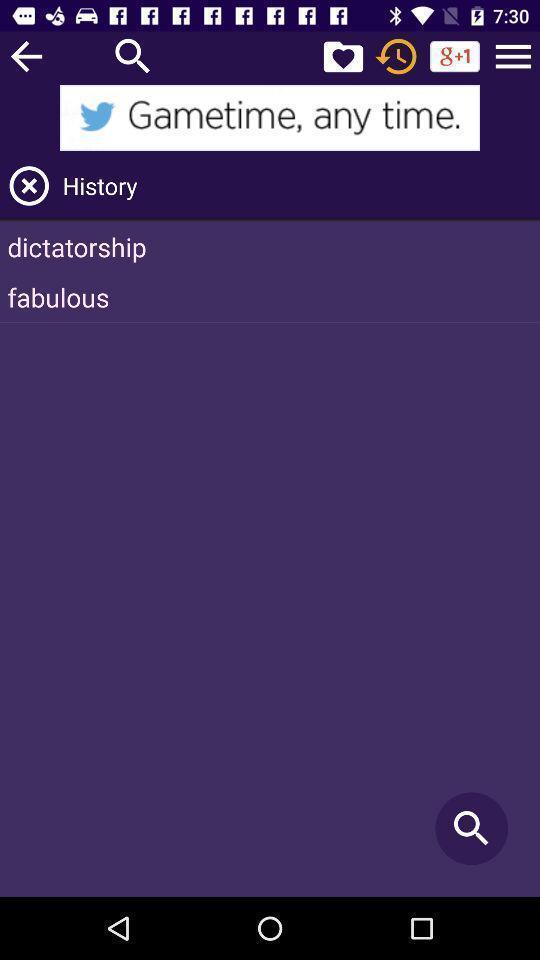What can you discern from this picture? Page showing list of history in the social app. 